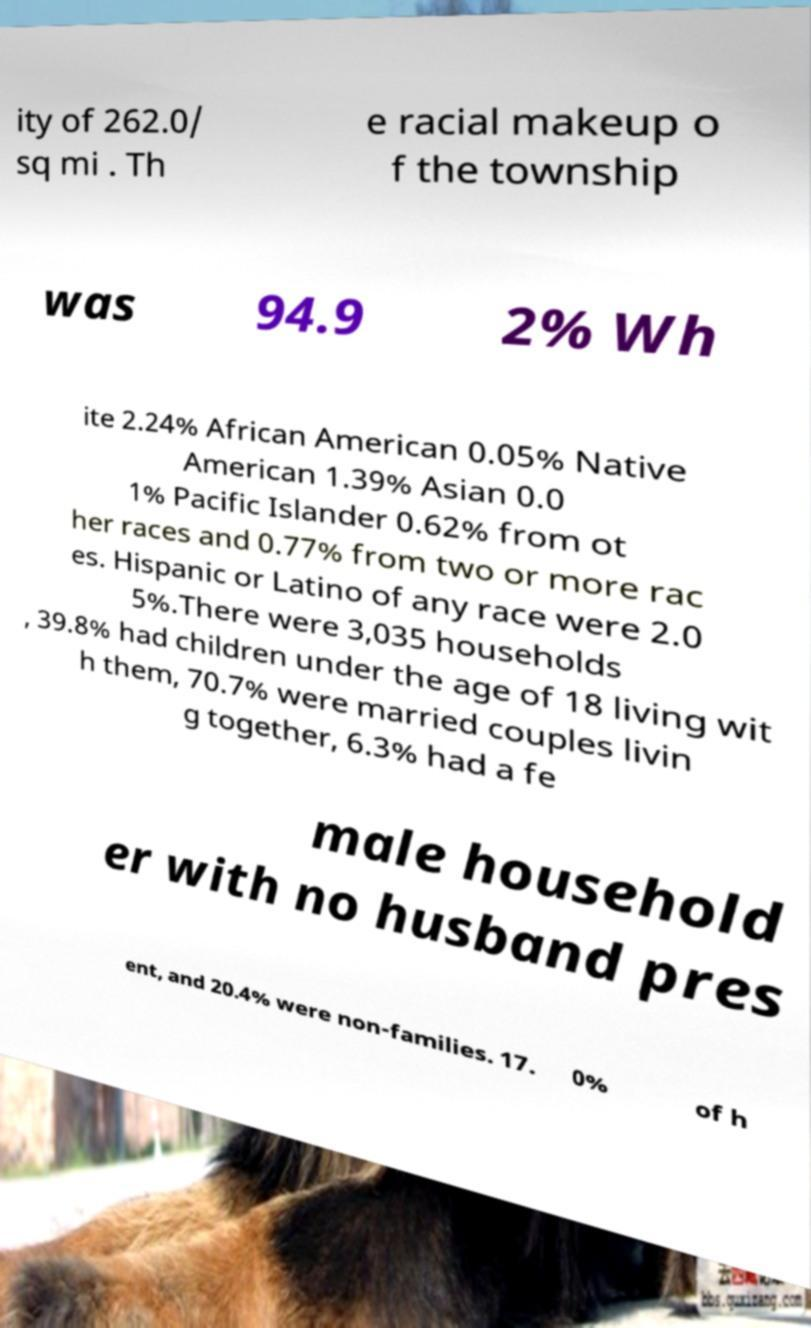Can you read and provide the text displayed in the image?This photo seems to have some interesting text. Can you extract and type it out for me? ity of 262.0/ sq mi . Th e racial makeup o f the township was 94.9 2% Wh ite 2.24% African American 0.05% Native American 1.39% Asian 0.0 1% Pacific Islander 0.62% from ot her races and 0.77% from two or more rac es. Hispanic or Latino of any race were 2.0 5%.There were 3,035 households , 39.8% had children under the age of 18 living wit h them, 70.7% were married couples livin g together, 6.3% had a fe male household er with no husband pres ent, and 20.4% were non-families. 17. 0% of h 